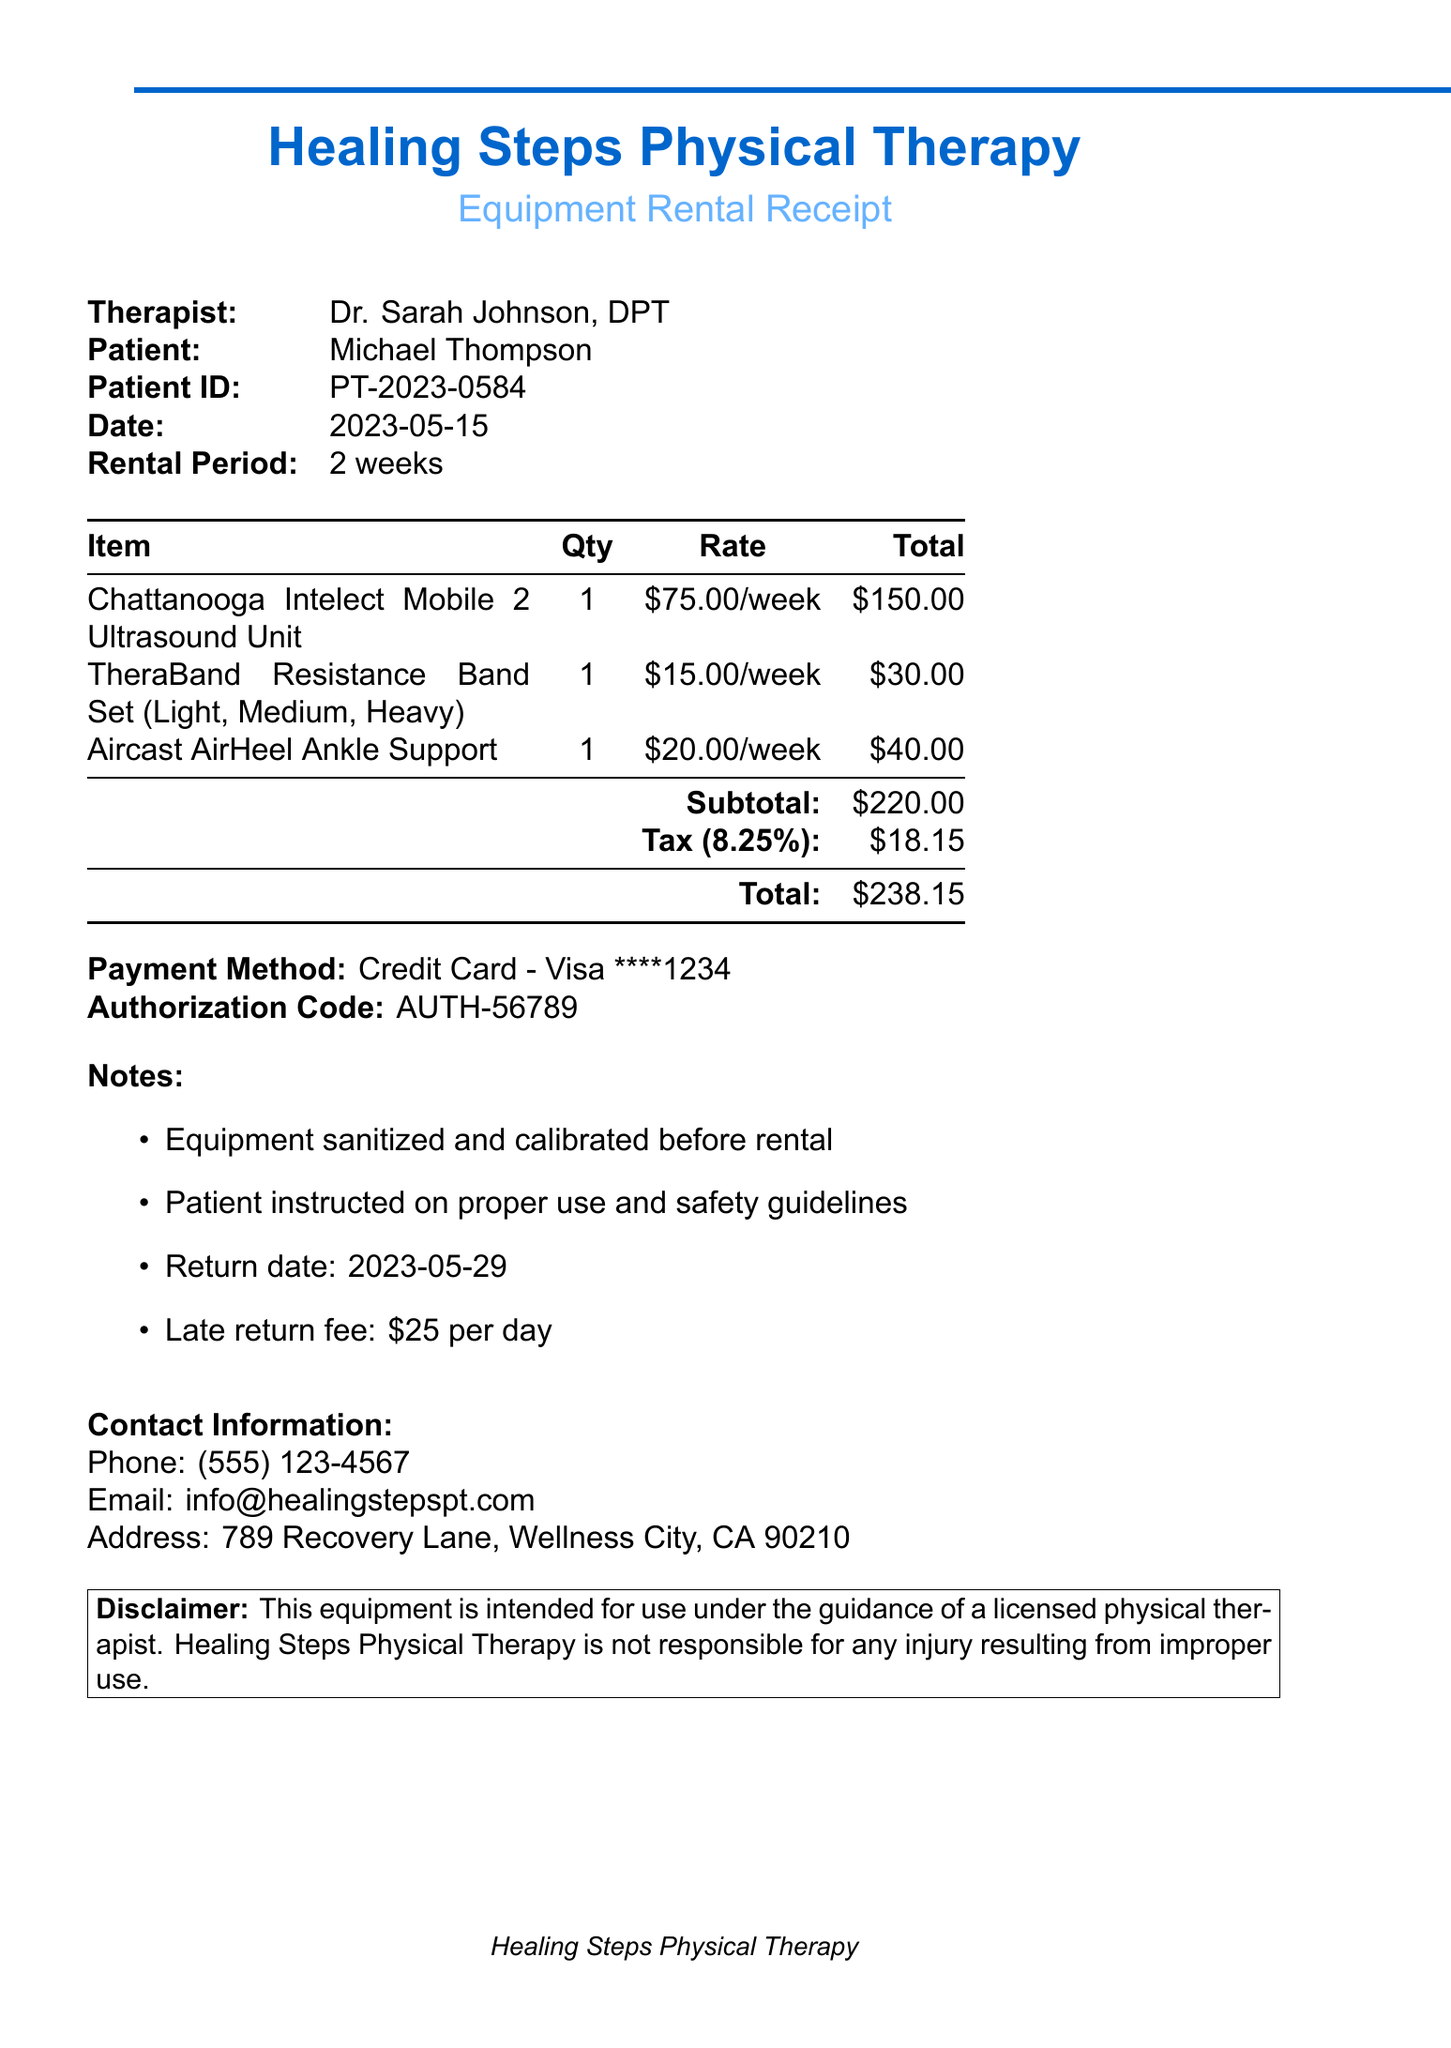What is the clinic name? The clinic name is listed at the top of the receipt.
Answer: Healing Steps Physical Therapy Who is the therapist? The therapist's name is provided in the document.
Answer: Dr. Sarah Johnson, DPT What is the rental period? The rental period is explicitly stated in the receipt details.
Answer: 2 weeks How much is the total amount due? The total amount is calculated at the bottom of the receipt.
Answer: $238.15 What item has the highest rental rate? The rental rates are given for each item, allowing comparison.
Answer: Chattanooga Intelect Mobile 2 Ultrasound Unit What is the tax rate applied? The tax rate is mentioned clearly in the document.
Answer: 8.25% When is the return date for the equipment? The return date is noted in the list of notes.
Answer: 2023-05-29 How much is the late return fee per day? The late return fee is specified in the notes section.
Answer: $25 per day What payment method was used? The payment method is provided in the financial details.
Answer: Credit Card - Visa ****1234 